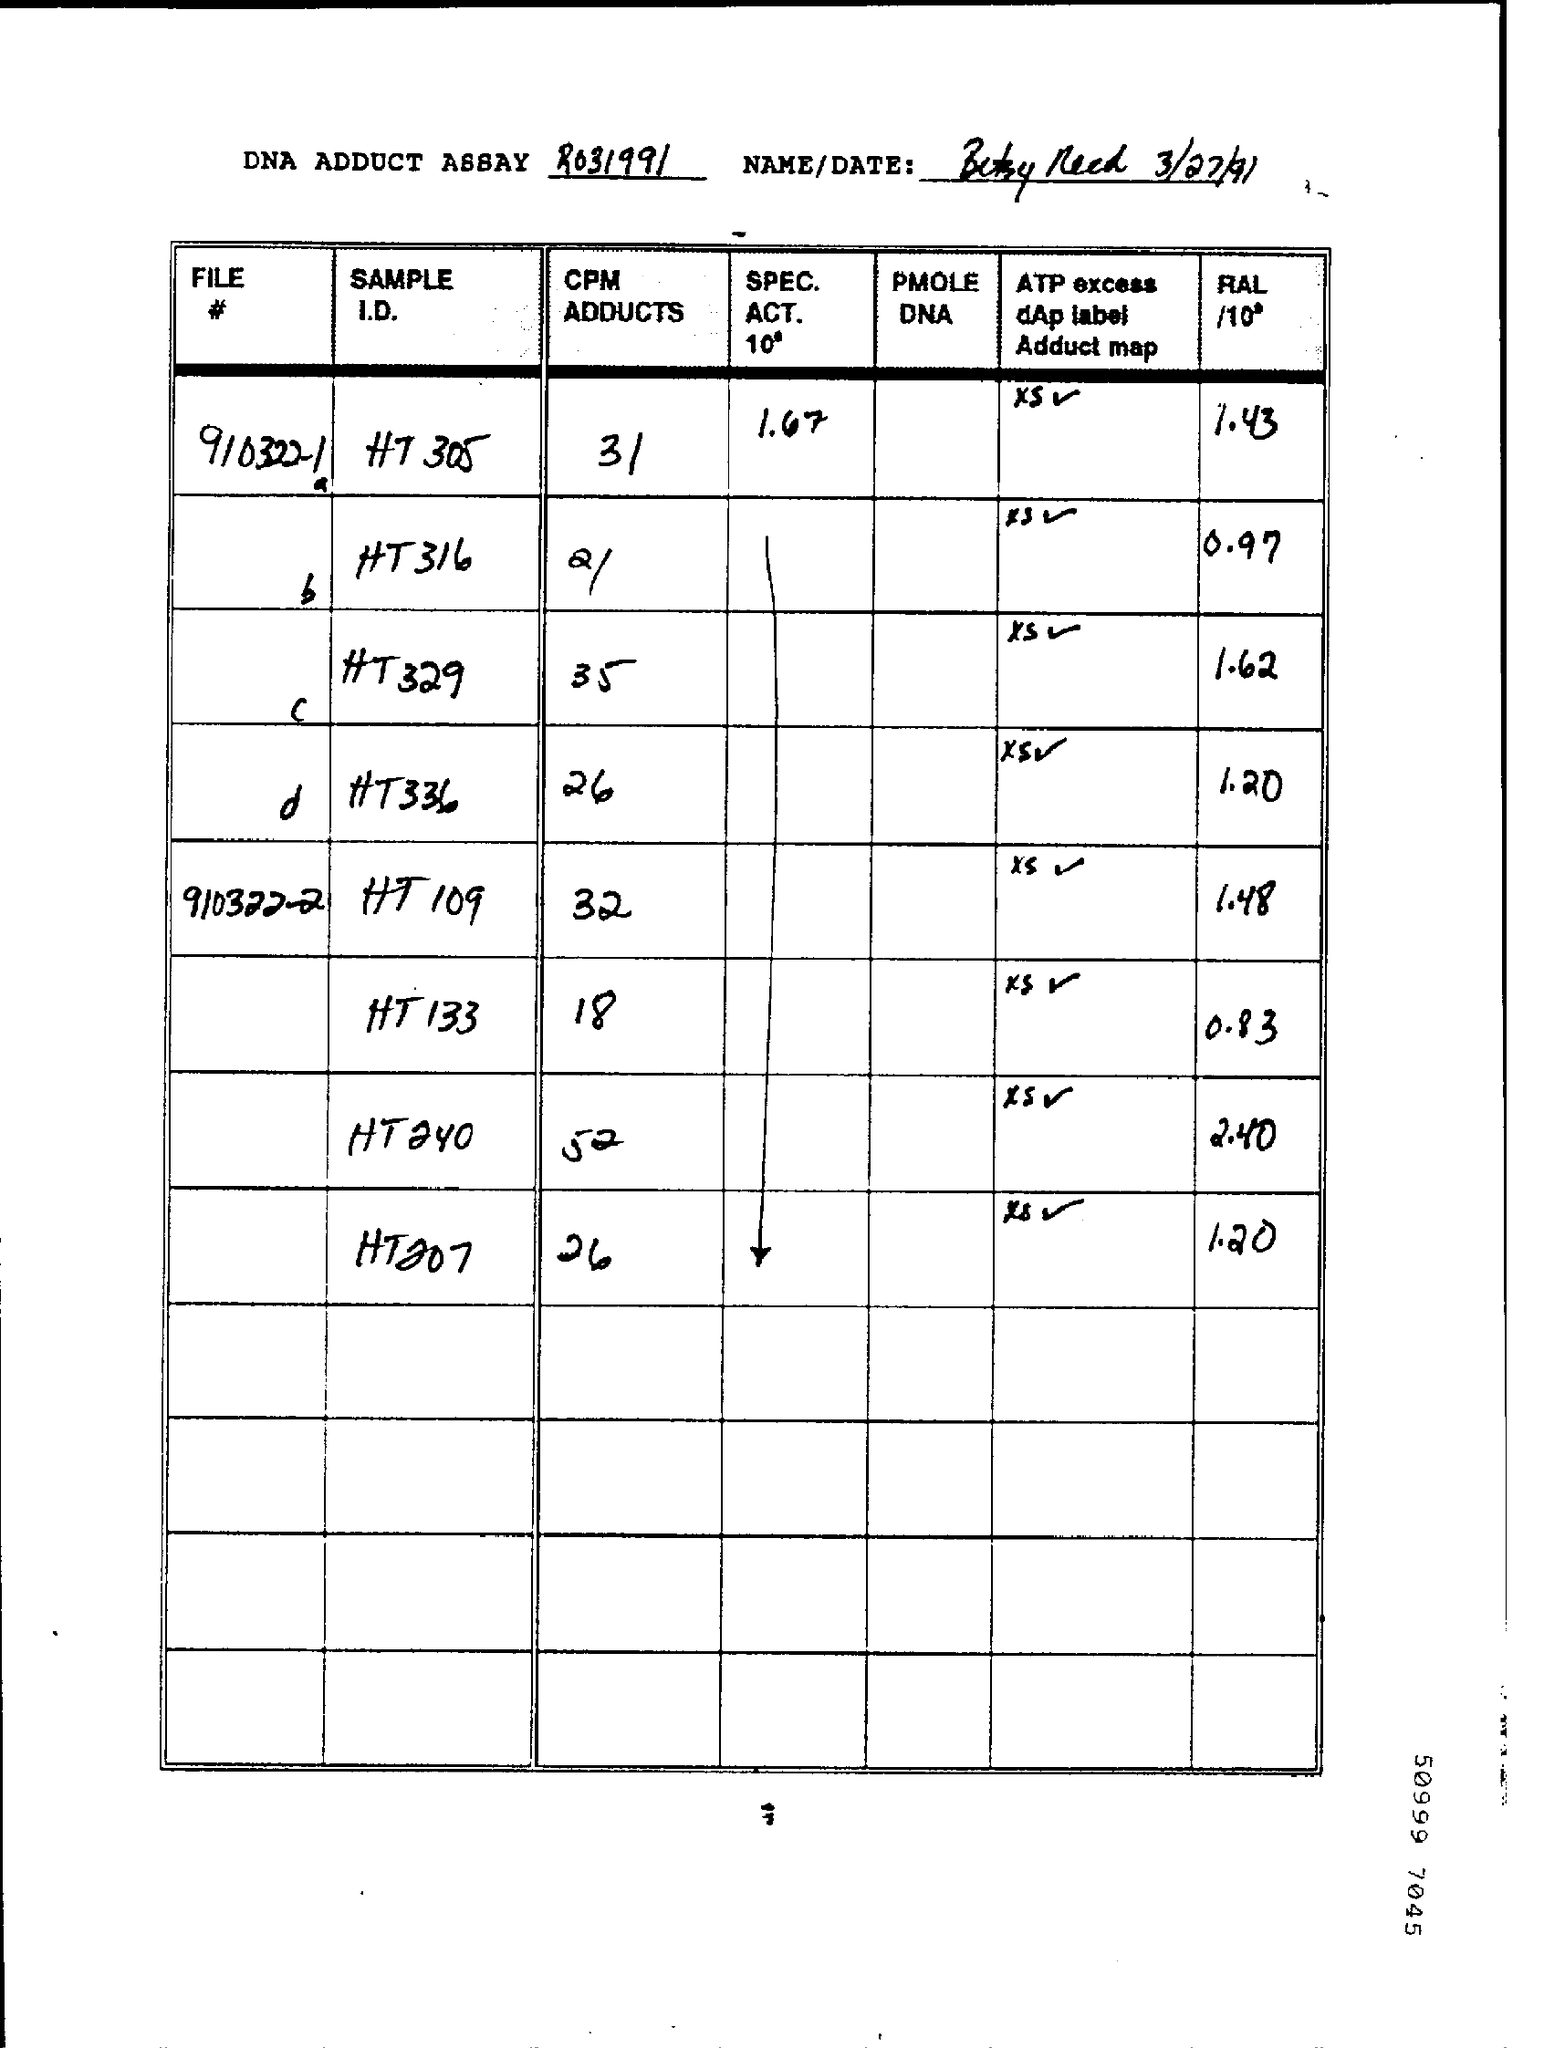Indicate a few pertinent items in this graphic. The CPM ADDUCTS for File # 9103221a is 31 and we need to extract information from it. The date is March 27th, 1991. 